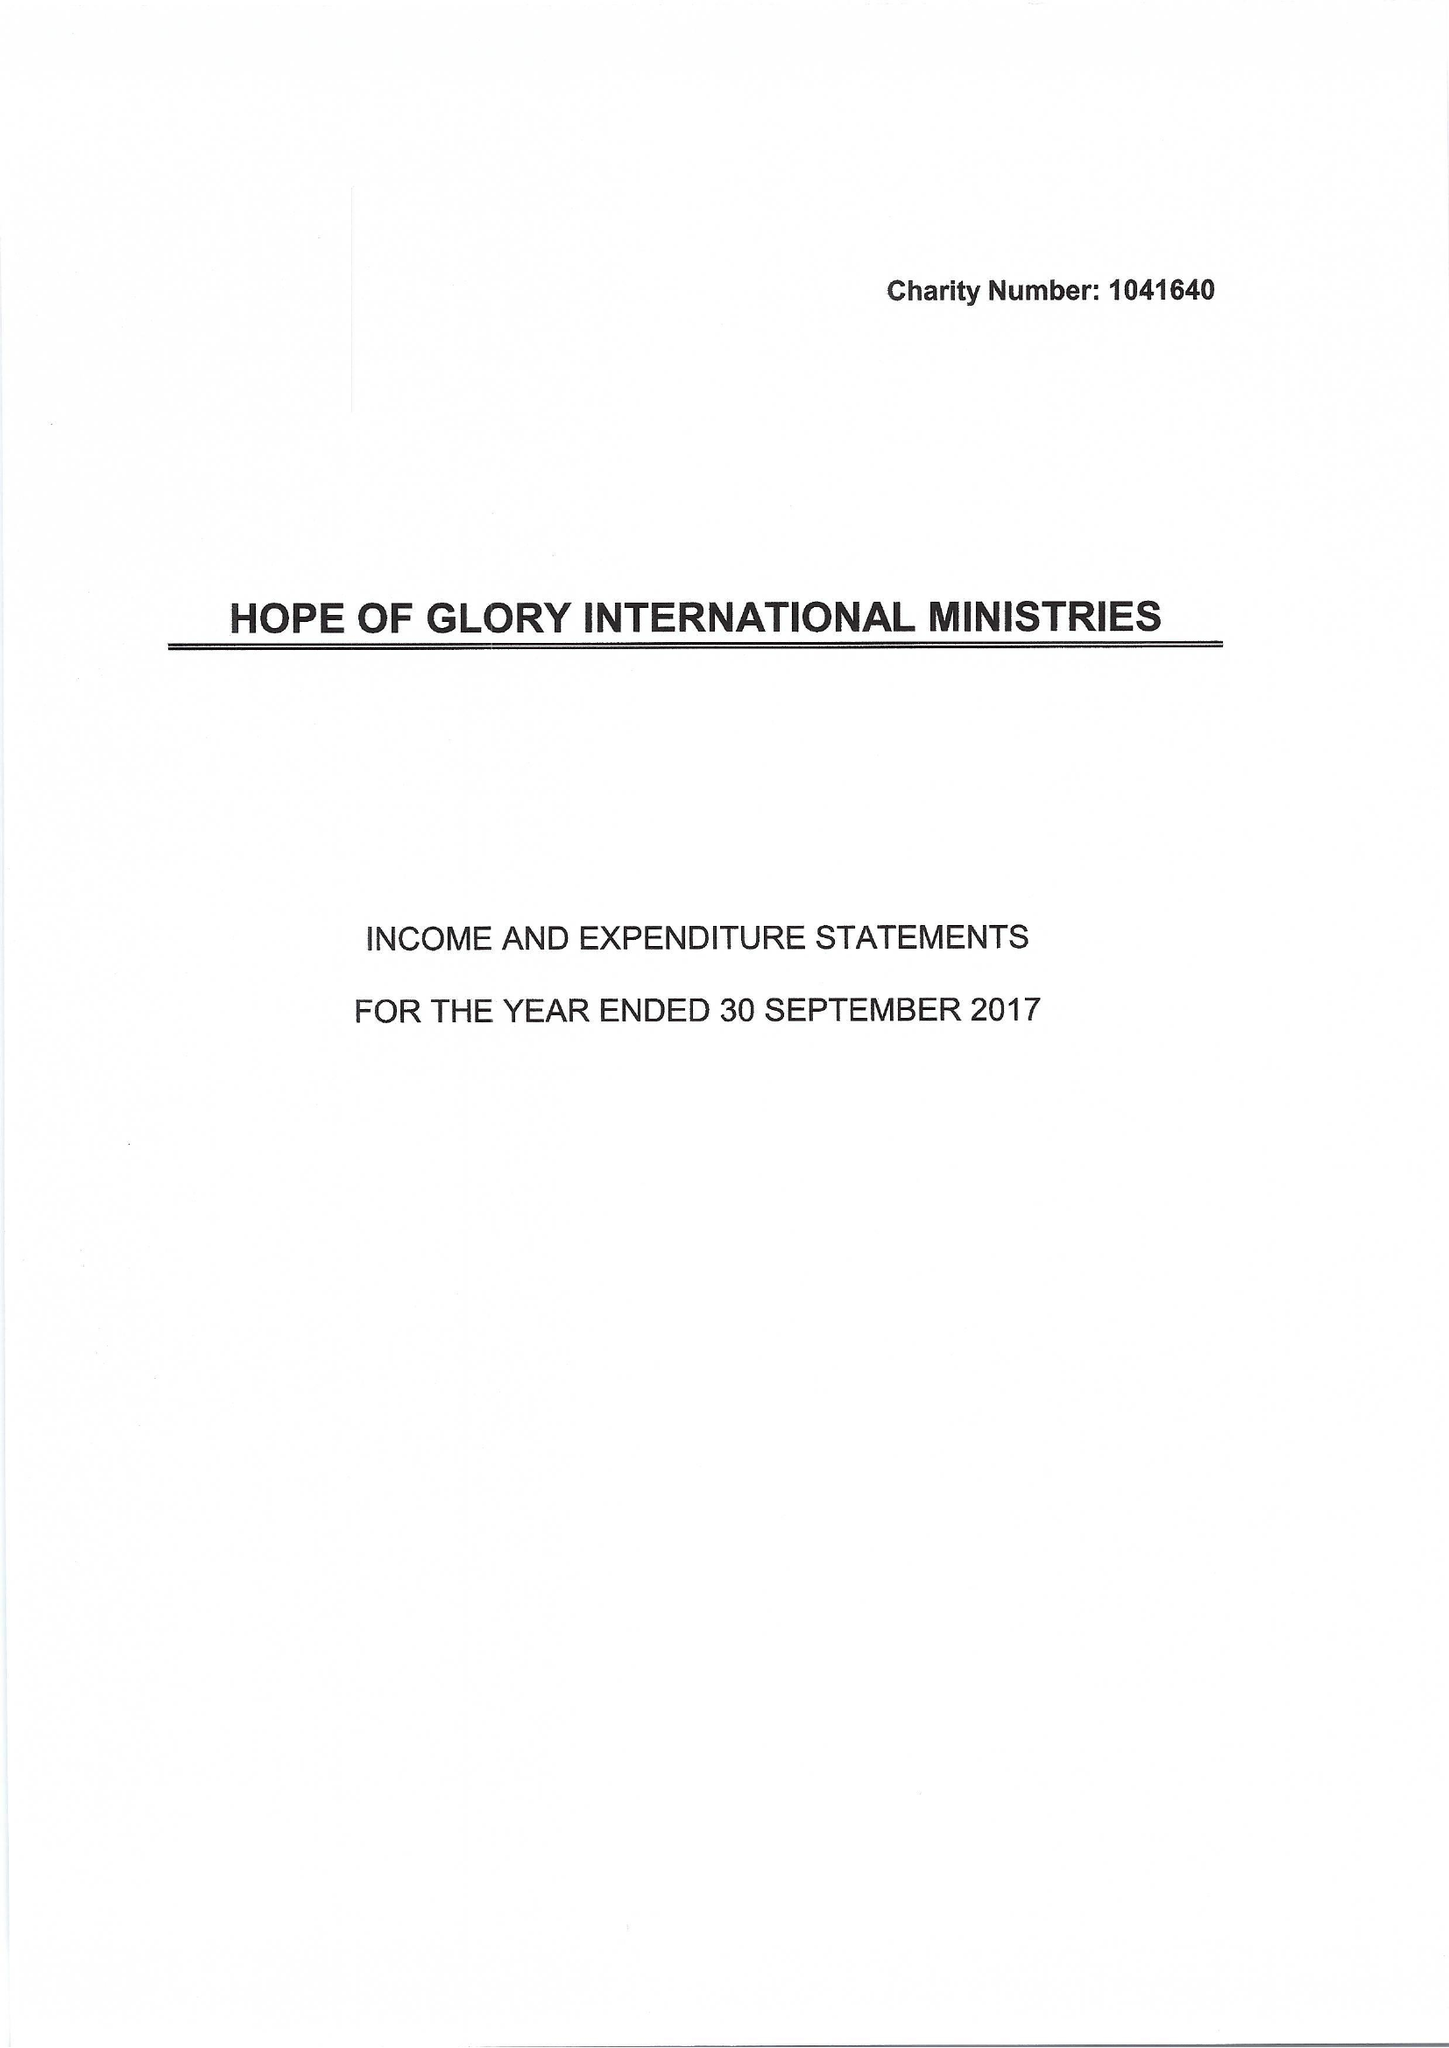What is the value for the address__street_line?
Answer the question using a single word or phrase. 18 UPLAND ROAD 